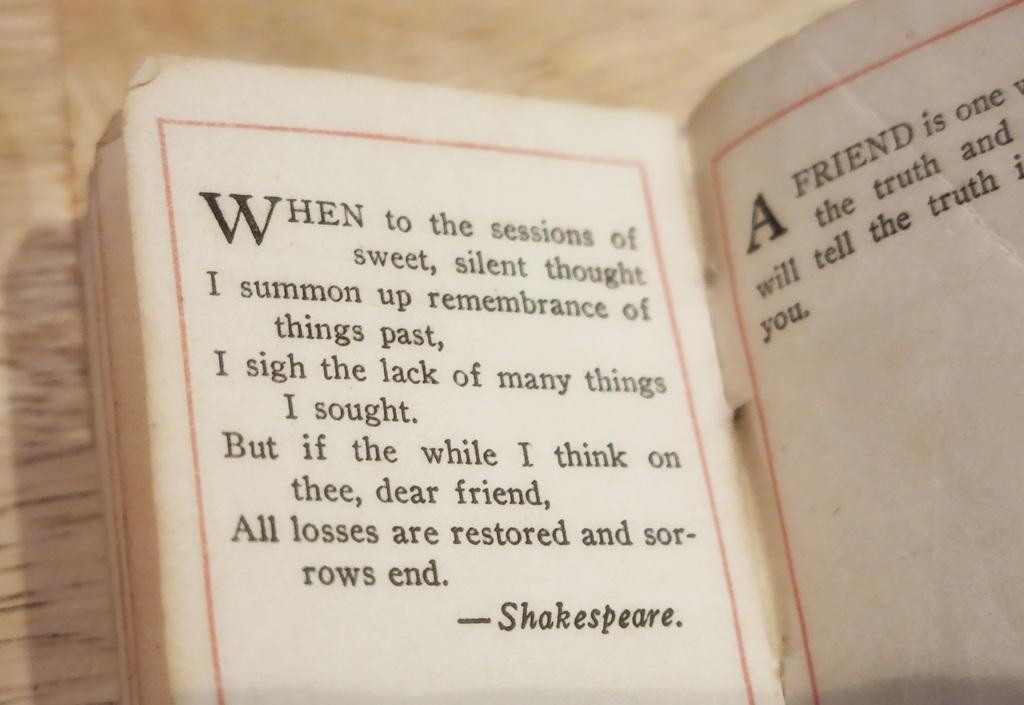Provide a one-sentence caption for the provided image. a quote in a book that is from Shakespeare. 